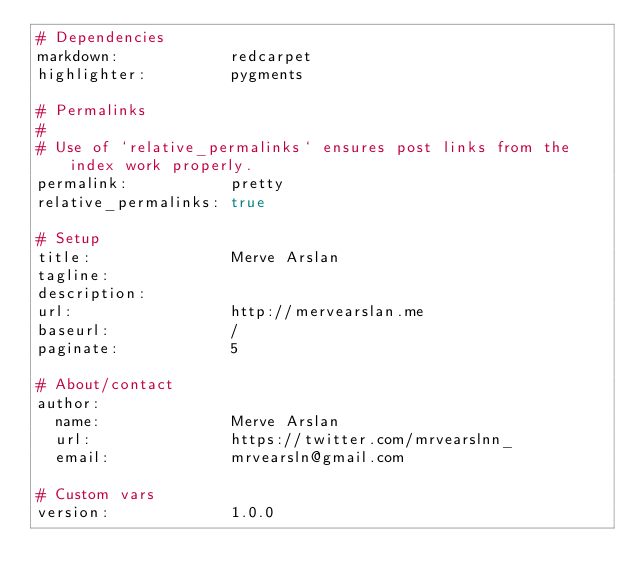<code> <loc_0><loc_0><loc_500><loc_500><_YAML_># Dependencies
markdown:            redcarpet
highlighter:         pygments

# Permalinks
#
# Use of `relative_permalinks` ensures post links from the index work properly.
permalink:           pretty
relative_permalinks: true

# Setup
title:               Merve Arslan
tagline:             
description:         
url:                 http://mervearslan.me
baseurl:             /
paginate:            5

# About/contact
author:
  name:              Merve Arslan
  url:               https://twitter.com/mrvearslnn_
  email:             mrvearsln@gmail.com

# Custom vars
version:             1.0.0
</code> 